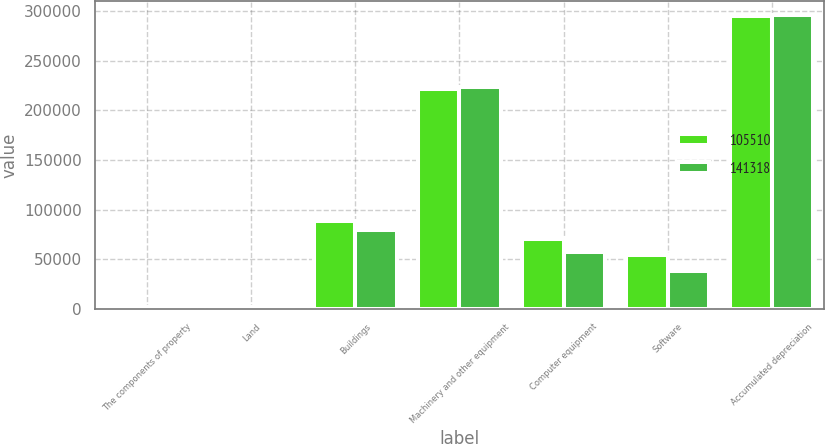<chart> <loc_0><loc_0><loc_500><loc_500><stacked_bar_chart><ecel><fcel>The components of property<fcel>Land<fcel>Buildings<fcel>Machinery and other equipment<fcel>Computer equipment<fcel>Software<fcel>Accumulated depreciation<nl><fcel>105510<fcel>2016<fcel>2404<fcel>88201<fcel>221325<fcel>70110<fcel>54451<fcel>295173<nl><fcel>141318<fcel>2015<fcel>2488<fcel>79182<fcel>223561<fcel>57338<fcel>38517<fcel>295576<nl></chart> 